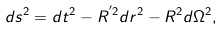Convert formula to latex. <formula><loc_0><loc_0><loc_500><loc_500>d s ^ { 2 } = d t ^ { 2 } - R ^ { ^ { \prime } 2 } d r ^ { 2 } - R ^ { 2 } d \Omega ^ { 2 } ,</formula> 